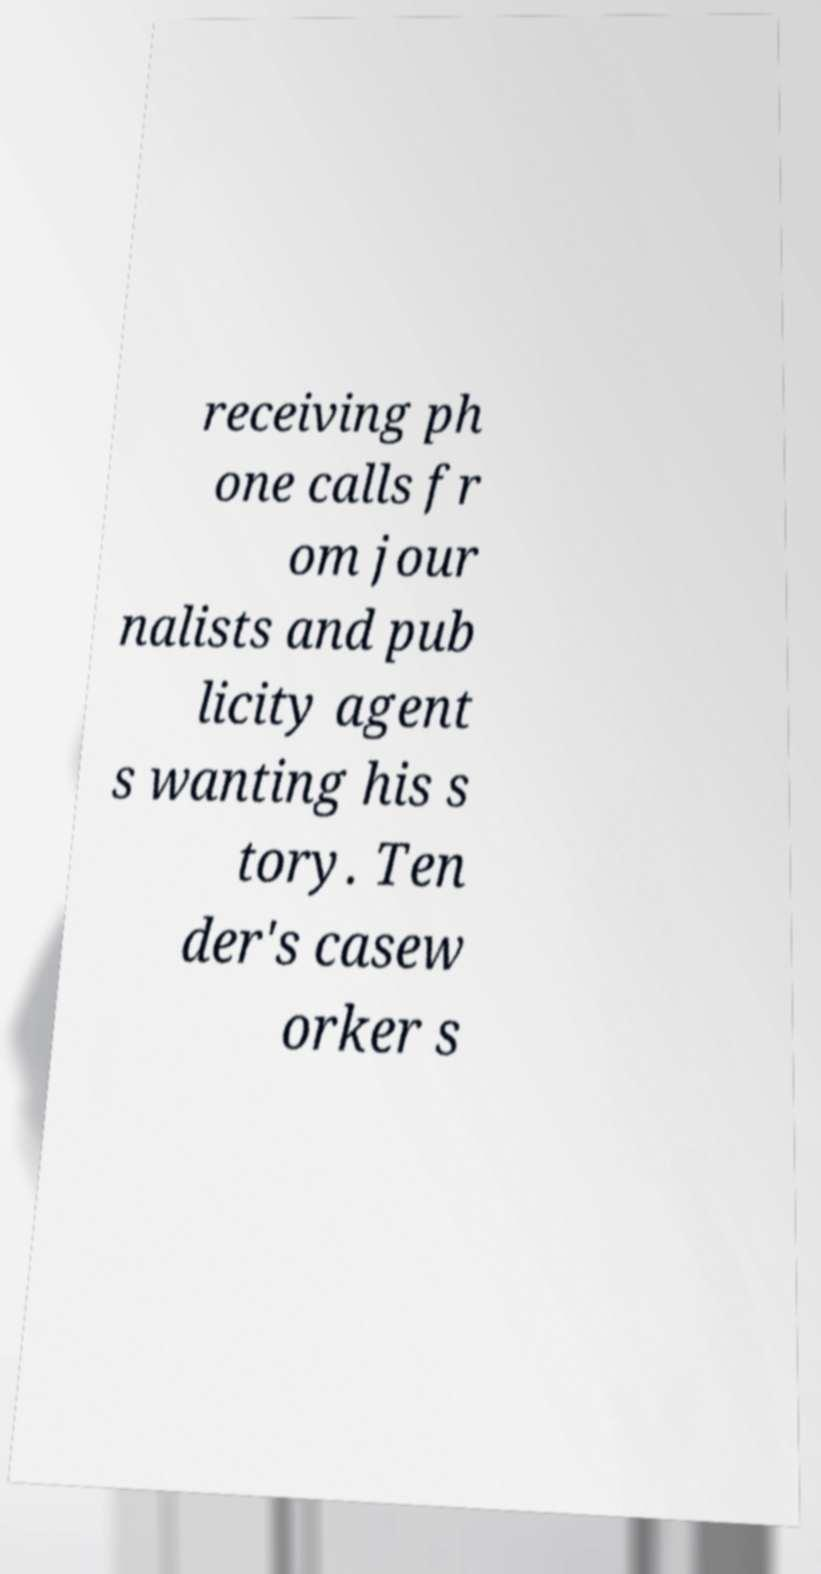For documentation purposes, I need the text within this image transcribed. Could you provide that? receiving ph one calls fr om jour nalists and pub licity agent s wanting his s tory. Ten der's casew orker s 